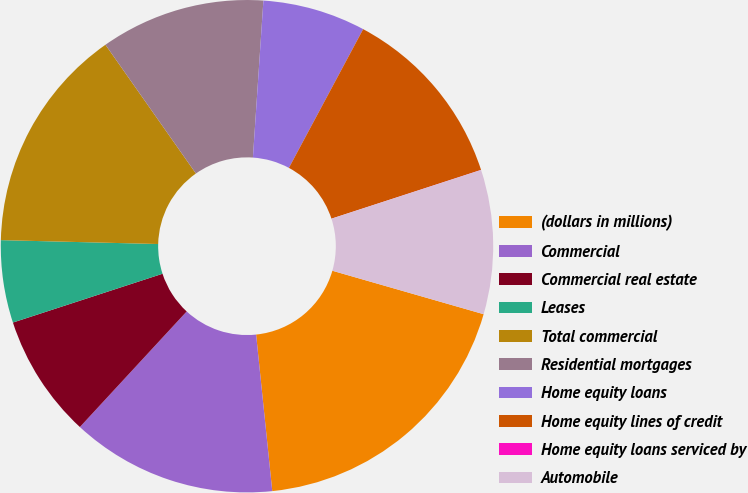Convert chart to OTSL. <chart><loc_0><loc_0><loc_500><loc_500><pie_chart><fcel>(dollars in millions)<fcel>Commercial<fcel>Commercial real estate<fcel>Leases<fcel>Total commercial<fcel>Residential mortgages<fcel>Home equity loans<fcel>Home equity lines of credit<fcel>Home equity loans serviced by<fcel>Automobile<nl><fcel>18.91%<fcel>13.51%<fcel>8.11%<fcel>5.41%<fcel>14.86%<fcel>10.81%<fcel>6.76%<fcel>12.16%<fcel>0.01%<fcel>9.46%<nl></chart> 